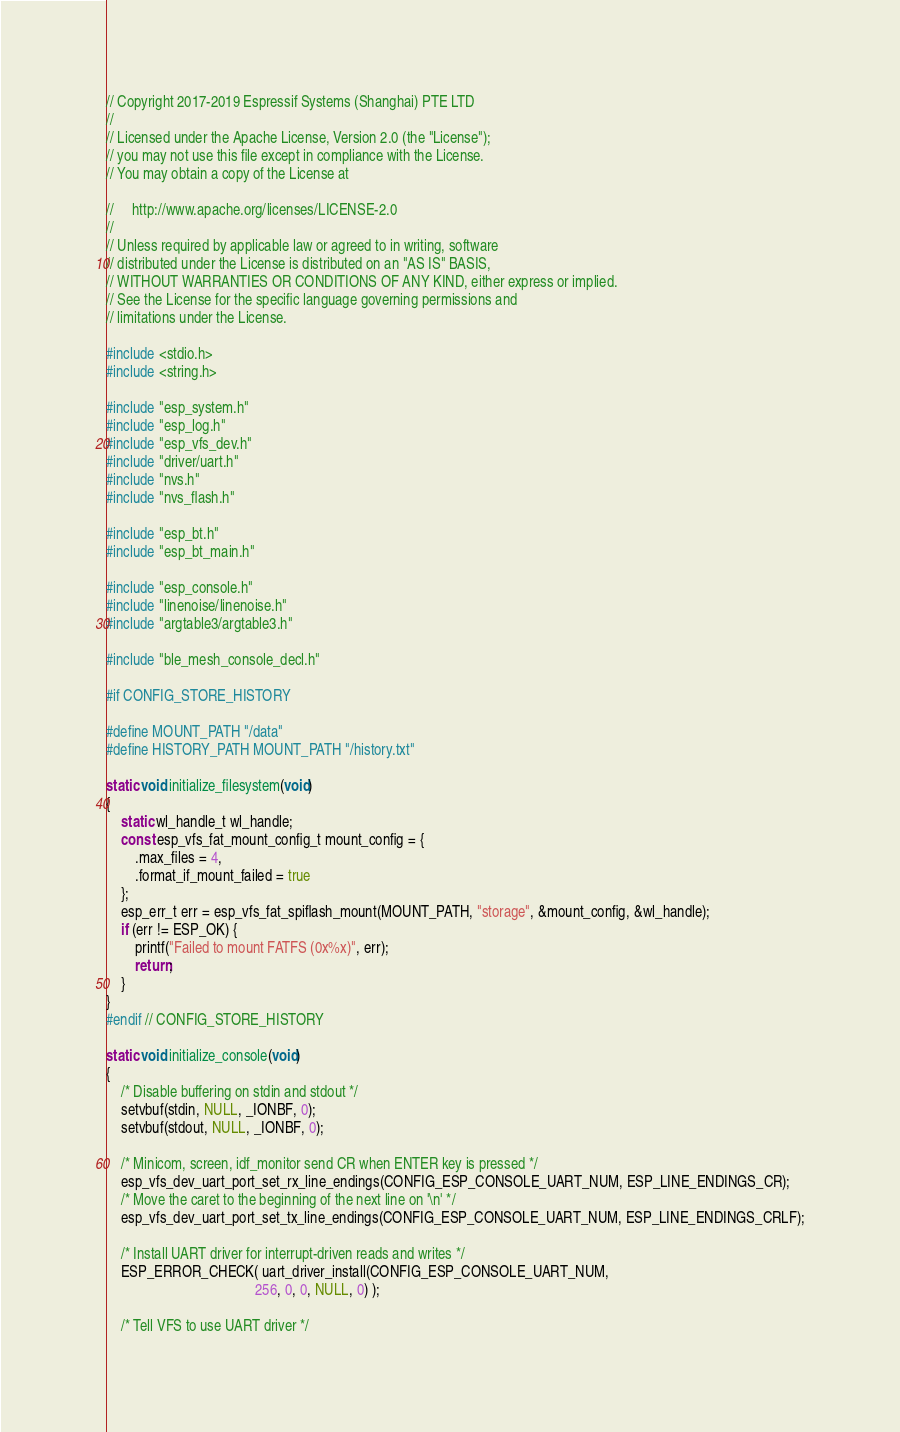<code> <loc_0><loc_0><loc_500><loc_500><_C_>// Copyright 2017-2019 Espressif Systems (Shanghai) PTE LTD
//
// Licensed under the Apache License, Version 2.0 (the "License");
// you may not use this file except in compliance with the License.
// You may obtain a copy of the License at

//     http://www.apache.org/licenses/LICENSE-2.0
//
// Unless required by applicable law or agreed to in writing, software
// distributed under the License is distributed on an "AS IS" BASIS,
// WITHOUT WARRANTIES OR CONDITIONS OF ANY KIND, either express or implied.
// See the License for the specific language governing permissions and
// limitations under the License.

#include <stdio.h>
#include <string.h>

#include "esp_system.h"
#include "esp_log.h"
#include "esp_vfs_dev.h"
#include "driver/uart.h"
#include "nvs.h"
#include "nvs_flash.h"

#include "esp_bt.h"
#include "esp_bt_main.h"

#include "esp_console.h"
#include "linenoise/linenoise.h"
#include "argtable3/argtable3.h"

#include "ble_mesh_console_decl.h"

#if CONFIG_STORE_HISTORY

#define MOUNT_PATH "/data"
#define HISTORY_PATH MOUNT_PATH "/history.txt"

static void initialize_filesystem(void)
{
    static wl_handle_t wl_handle;
    const esp_vfs_fat_mount_config_t mount_config = {
        .max_files = 4,
        .format_if_mount_failed = true
    };
    esp_err_t err = esp_vfs_fat_spiflash_mount(MOUNT_PATH, "storage", &mount_config, &wl_handle);
    if (err != ESP_OK) {
        printf("Failed to mount FATFS (0x%x)", err);
        return;
    }
}
#endif // CONFIG_STORE_HISTORY

static void initialize_console(void)
{
    /* Disable buffering on stdin and stdout */
    setvbuf(stdin, NULL, _IONBF, 0);
    setvbuf(stdout, NULL, _IONBF, 0);

    /* Minicom, screen, idf_monitor send CR when ENTER key is pressed */
    esp_vfs_dev_uart_port_set_rx_line_endings(CONFIG_ESP_CONSOLE_UART_NUM, ESP_LINE_ENDINGS_CR);
    /* Move the caret to the beginning of the next line on '\n' */
    esp_vfs_dev_uart_port_set_tx_line_endings(CONFIG_ESP_CONSOLE_UART_NUM, ESP_LINE_ENDINGS_CRLF);

    /* Install UART driver for interrupt-driven reads and writes */
    ESP_ERROR_CHECK( uart_driver_install(CONFIG_ESP_CONSOLE_UART_NUM,
                                         256, 0, 0, NULL, 0) );

    /* Tell VFS to use UART driver */</code> 